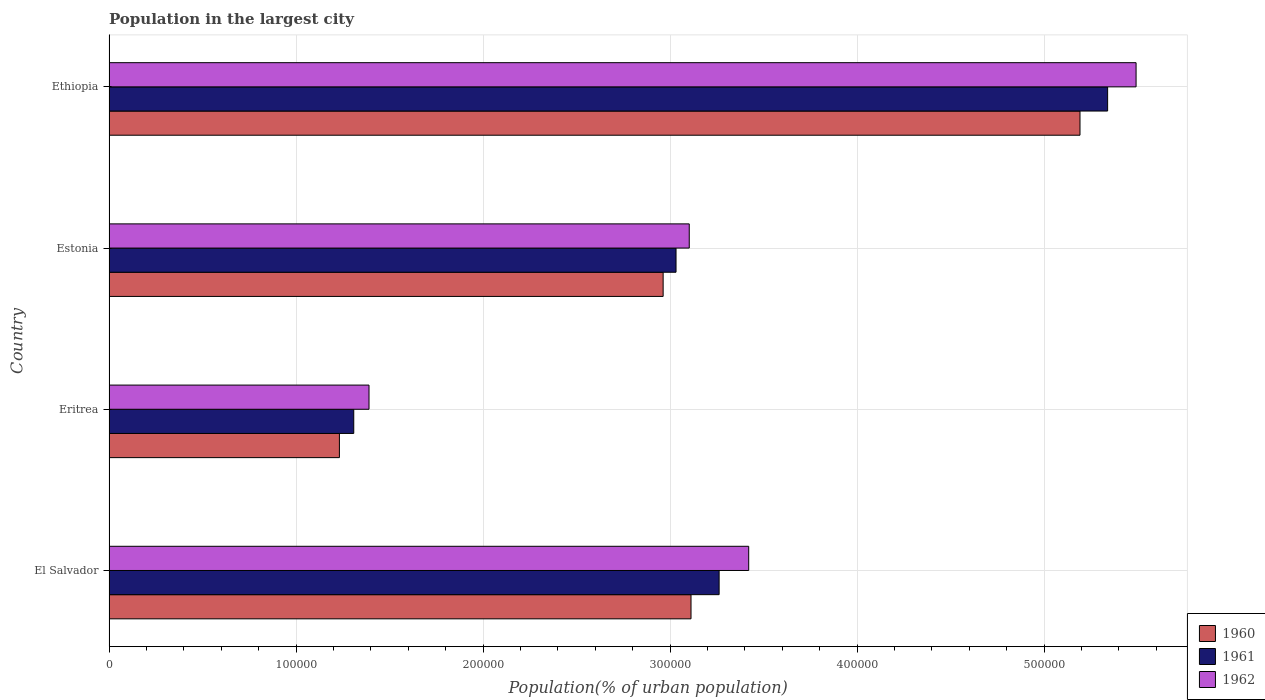How many groups of bars are there?
Keep it short and to the point. 4. Are the number of bars per tick equal to the number of legend labels?
Ensure brevity in your answer.  Yes. How many bars are there on the 4th tick from the bottom?
Offer a terse response. 3. What is the label of the 4th group of bars from the top?
Provide a succinct answer. El Salvador. What is the population in the largest city in 1962 in Estonia?
Keep it short and to the point. 3.10e+05. Across all countries, what is the maximum population in the largest city in 1960?
Keep it short and to the point. 5.19e+05. Across all countries, what is the minimum population in the largest city in 1960?
Offer a terse response. 1.23e+05. In which country was the population in the largest city in 1962 maximum?
Ensure brevity in your answer.  Ethiopia. In which country was the population in the largest city in 1960 minimum?
Give a very brief answer. Eritrea. What is the total population in the largest city in 1962 in the graph?
Your response must be concise. 1.34e+06. What is the difference between the population in the largest city in 1960 in El Salvador and that in Eritrea?
Make the answer very short. 1.88e+05. What is the difference between the population in the largest city in 1960 in El Salvador and the population in the largest city in 1961 in Ethiopia?
Provide a succinct answer. -2.23e+05. What is the average population in the largest city in 1961 per country?
Offer a terse response. 3.24e+05. What is the difference between the population in the largest city in 1962 and population in the largest city in 1960 in Estonia?
Make the answer very short. 1.40e+04. What is the ratio of the population in the largest city in 1960 in Eritrea to that in Ethiopia?
Provide a succinct answer. 0.24. Is the difference between the population in the largest city in 1962 in El Salvador and Ethiopia greater than the difference between the population in the largest city in 1960 in El Salvador and Ethiopia?
Provide a succinct answer. Yes. What is the difference between the highest and the second highest population in the largest city in 1962?
Offer a terse response. 2.07e+05. What is the difference between the highest and the lowest population in the largest city in 1962?
Offer a very short reply. 4.10e+05. How many bars are there?
Your answer should be compact. 12. Are all the bars in the graph horizontal?
Ensure brevity in your answer.  Yes. How many countries are there in the graph?
Provide a short and direct response. 4. Does the graph contain grids?
Give a very brief answer. Yes. Where does the legend appear in the graph?
Provide a short and direct response. Bottom right. How many legend labels are there?
Your response must be concise. 3. How are the legend labels stacked?
Provide a succinct answer. Vertical. What is the title of the graph?
Keep it short and to the point. Population in the largest city. Does "1986" appear as one of the legend labels in the graph?
Provide a succinct answer. No. What is the label or title of the X-axis?
Your answer should be compact. Population(% of urban population). What is the Population(% of urban population) in 1960 in El Salvador?
Your answer should be compact. 3.11e+05. What is the Population(% of urban population) in 1961 in El Salvador?
Ensure brevity in your answer.  3.26e+05. What is the Population(% of urban population) of 1962 in El Salvador?
Provide a succinct answer. 3.42e+05. What is the Population(% of urban population) of 1960 in Eritrea?
Your response must be concise. 1.23e+05. What is the Population(% of urban population) of 1961 in Eritrea?
Your response must be concise. 1.31e+05. What is the Population(% of urban population) in 1962 in Eritrea?
Ensure brevity in your answer.  1.39e+05. What is the Population(% of urban population) in 1960 in Estonia?
Your response must be concise. 2.96e+05. What is the Population(% of urban population) in 1961 in Estonia?
Ensure brevity in your answer.  3.03e+05. What is the Population(% of urban population) in 1962 in Estonia?
Offer a very short reply. 3.10e+05. What is the Population(% of urban population) in 1960 in Ethiopia?
Your response must be concise. 5.19e+05. What is the Population(% of urban population) of 1961 in Ethiopia?
Offer a terse response. 5.34e+05. What is the Population(% of urban population) of 1962 in Ethiopia?
Give a very brief answer. 5.49e+05. Across all countries, what is the maximum Population(% of urban population) in 1960?
Offer a very short reply. 5.19e+05. Across all countries, what is the maximum Population(% of urban population) of 1961?
Your answer should be compact. 5.34e+05. Across all countries, what is the maximum Population(% of urban population) of 1962?
Give a very brief answer. 5.49e+05. Across all countries, what is the minimum Population(% of urban population) of 1960?
Keep it short and to the point. 1.23e+05. Across all countries, what is the minimum Population(% of urban population) in 1961?
Your answer should be compact. 1.31e+05. Across all countries, what is the minimum Population(% of urban population) in 1962?
Make the answer very short. 1.39e+05. What is the total Population(% of urban population) in 1960 in the graph?
Offer a very short reply. 1.25e+06. What is the total Population(% of urban population) in 1961 in the graph?
Offer a terse response. 1.29e+06. What is the total Population(% of urban population) in 1962 in the graph?
Keep it short and to the point. 1.34e+06. What is the difference between the Population(% of urban population) in 1960 in El Salvador and that in Eritrea?
Make the answer very short. 1.88e+05. What is the difference between the Population(% of urban population) in 1961 in El Salvador and that in Eritrea?
Offer a terse response. 1.95e+05. What is the difference between the Population(% of urban population) in 1962 in El Salvador and that in Eritrea?
Your response must be concise. 2.03e+05. What is the difference between the Population(% of urban population) of 1960 in El Salvador and that in Estonia?
Offer a terse response. 1.49e+04. What is the difference between the Population(% of urban population) in 1961 in El Salvador and that in Estonia?
Keep it short and to the point. 2.30e+04. What is the difference between the Population(% of urban population) in 1962 in El Salvador and that in Estonia?
Make the answer very short. 3.18e+04. What is the difference between the Population(% of urban population) in 1960 in El Salvador and that in Ethiopia?
Make the answer very short. -2.08e+05. What is the difference between the Population(% of urban population) in 1961 in El Salvador and that in Ethiopia?
Your response must be concise. -2.08e+05. What is the difference between the Population(% of urban population) of 1962 in El Salvador and that in Ethiopia?
Provide a succinct answer. -2.07e+05. What is the difference between the Population(% of urban population) of 1960 in Eritrea and that in Estonia?
Make the answer very short. -1.73e+05. What is the difference between the Population(% of urban population) in 1961 in Eritrea and that in Estonia?
Your answer should be compact. -1.72e+05. What is the difference between the Population(% of urban population) of 1962 in Eritrea and that in Estonia?
Give a very brief answer. -1.71e+05. What is the difference between the Population(% of urban population) in 1960 in Eritrea and that in Ethiopia?
Your answer should be very brief. -3.96e+05. What is the difference between the Population(% of urban population) in 1961 in Eritrea and that in Ethiopia?
Give a very brief answer. -4.03e+05. What is the difference between the Population(% of urban population) of 1962 in Eritrea and that in Ethiopia?
Your answer should be very brief. -4.10e+05. What is the difference between the Population(% of urban population) of 1960 in Estonia and that in Ethiopia?
Provide a succinct answer. -2.23e+05. What is the difference between the Population(% of urban population) of 1961 in Estonia and that in Ethiopia?
Provide a short and direct response. -2.31e+05. What is the difference between the Population(% of urban population) of 1962 in Estonia and that in Ethiopia?
Ensure brevity in your answer.  -2.39e+05. What is the difference between the Population(% of urban population) in 1960 in El Salvador and the Population(% of urban population) in 1961 in Eritrea?
Make the answer very short. 1.80e+05. What is the difference between the Population(% of urban population) of 1960 in El Salvador and the Population(% of urban population) of 1962 in Eritrea?
Your response must be concise. 1.72e+05. What is the difference between the Population(% of urban population) of 1961 in El Salvador and the Population(% of urban population) of 1962 in Eritrea?
Make the answer very short. 1.87e+05. What is the difference between the Population(% of urban population) in 1960 in El Salvador and the Population(% of urban population) in 1961 in Estonia?
Provide a succinct answer. 8011. What is the difference between the Population(% of urban population) of 1960 in El Salvador and the Population(% of urban population) of 1962 in Estonia?
Make the answer very short. 942. What is the difference between the Population(% of urban population) of 1961 in El Salvador and the Population(% of urban population) of 1962 in Estonia?
Offer a terse response. 1.60e+04. What is the difference between the Population(% of urban population) of 1960 in El Salvador and the Population(% of urban population) of 1961 in Ethiopia?
Provide a short and direct response. -2.23e+05. What is the difference between the Population(% of urban population) of 1960 in El Salvador and the Population(% of urban population) of 1962 in Ethiopia?
Ensure brevity in your answer.  -2.38e+05. What is the difference between the Population(% of urban population) in 1961 in El Salvador and the Population(% of urban population) in 1962 in Ethiopia?
Provide a short and direct response. -2.23e+05. What is the difference between the Population(% of urban population) of 1960 in Eritrea and the Population(% of urban population) of 1961 in Estonia?
Offer a terse response. -1.80e+05. What is the difference between the Population(% of urban population) of 1960 in Eritrea and the Population(% of urban population) of 1962 in Estonia?
Your answer should be very brief. -1.87e+05. What is the difference between the Population(% of urban population) in 1961 in Eritrea and the Population(% of urban population) in 1962 in Estonia?
Ensure brevity in your answer.  -1.79e+05. What is the difference between the Population(% of urban population) in 1960 in Eritrea and the Population(% of urban population) in 1961 in Ethiopia?
Your answer should be very brief. -4.11e+05. What is the difference between the Population(% of urban population) in 1960 in Eritrea and the Population(% of urban population) in 1962 in Ethiopia?
Your answer should be very brief. -4.26e+05. What is the difference between the Population(% of urban population) of 1961 in Eritrea and the Population(% of urban population) of 1962 in Ethiopia?
Offer a very short reply. -4.18e+05. What is the difference between the Population(% of urban population) in 1960 in Estonia and the Population(% of urban population) in 1961 in Ethiopia?
Keep it short and to the point. -2.38e+05. What is the difference between the Population(% of urban population) of 1960 in Estonia and the Population(% of urban population) of 1962 in Ethiopia?
Make the answer very short. -2.53e+05. What is the difference between the Population(% of urban population) of 1961 in Estonia and the Population(% of urban population) of 1962 in Ethiopia?
Your answer should be compact. -2.46e+05. What is the average Population(% of urban population) of 1960 per country?
Offer a terse response. 3.12e+05. What is the average Population(% of urban population) in 1961 per country?
Provide a short and direct response. 3.24e+05. What is the average Population(% of urban population) in 1962 per country?
Provide a short and direct response. 3.35e+05. What is the difference between the Population(% of urban population) of 1960 and Population(% of urban population) of 1961 in El Salvador?
Your response must be concise. -1.50e+04. What is the difference between the Population(% of urban population) in 1960 and Population(% of urban population) in 1962 in El Salvador?
Provide a short and direct response. -3.08e+04. What is the difference between the Population(% of urban population) of 1961 and Population(% of urban population) of 1962 in El Salvador?
Keep it short and to the point. -1.58e+04. What is the difference between the Population(% of urban population) in 1960 and Population(% of urban population) in 1961 in Eritrea?
Make the answer very short. -7673. What is the difference between the Population(% of urban population) in 1960 and Population(% of urban population) in 1962 in Eritrea?
Ensure brevity in your answer.  -1.58e+04. What is the difference between the Population(% of urban population) in 1961 and Population(% of urban population) in 1962 in Eritrea?
Offer a terse response. -8161. What is the difference between the Population(% of urban population) of 1960 and Population(% of urban population) of 1961 in Estonia?
Provide a short and direct response. -6898. What is the difference between the Population(% of urban population) in 1960 and Population(% of urban population) in 1962 in Estonia?
Your answer should be compact. -1.40e+04. What is the difference between the Population(% of urban population) in 1961 and Population(% of urban population) in 1962 in Estonia?
Provide a succinct answer. -7069. What is the difference between the Population(% of urban population) of 1960 and Population(% of urban population) of 1961 in Ethiopia?
Offer a very short reply. -1.48e+04. What is the difference between the Population(% of urban population) in 1960 and Population(% of urban population) in 1962 in Ethiopia?
Your response must be concise. -3.00e+04. What is the difference between the Population(% of urban population) in 1961 and Population(% of urban population) in 1962 in Ethiopia?
Offer a terse response. -1.52e+04. What is the ratio of the Population(% of urban population) of 1960 in El Salvador to that in Eritrea?
Keep it short and to the point. 2.53. What is the ratio of the Population(% of urban population) of 1961 in El Salvador to that in Eritrea?
Provide a succinct answer. 2.49. What is the ratio of the Population(% of urban population) in 1962 in El Salvador to that in Eritrea?
Provide a succinct answer. 2.46. What is the ratio of the Population(% of urban population) of 1960 in El Salvador to that in Estonia?
Your answer should be very brief. 1.05. What is the ratio of the Population(% of urban population) in 1961 in El Salvador to that in Estonia?
Provide a short and direct response. 1.08. What is the ratio of the Population(% of urban population) of 1962 in El Salvador to that in Estonia?
Your answer should be compact. 1.1. What is the ratio of the Population(% of urban population) of 1960 in El Salvador to that in Ethiopia?
Give a very brief answer. 0.6. What is the ratio of the Population(% of urban population) of 1961 in El Salvador to that in Ethiopia?
Keep it short and to the point. 0.61. What is the ratio of the Population(% of urban population) of 1962 in El Salvador to that in Ethiopia?
Keep it short and to the point. 0.62. What is the ratio of the Population(% of urban population) in 1960 in Eritrea to that in Estonia?
Offer a very short reply. 0.42. What is the ratio of the Population(% of urban population) of 1961 in Eritrea to that in Estonia?
Your answer should be very brief. 0.43. What is the ratio of the Population(% of urban population) of 1962 in Eritrea to that in Estonia?
Give a very brief answer. 0.45. What is the ratio of the Population(% of urban population) of 1960 in Eritrea to that in Ethiopia?
Ensure brevity in your answer.  0.24. What is the ratio of the Population(% of urban population) in 1961 in Eritrea to that in Ethiopia?
Offer a terse response. 0.25. What is the ratio of the Population(% of urban population) in 1962 in Eritrea to that in Ethiopia?
Provide a succinct answer. 0.25. What is the ratio of the Population(% of urban population) of 1960 in Estonia to that in Ethiopia?
Your answer should be compact. 0.57. What is the ratio of the Population(% of urban population) of 1961 in Estonia to that in Ethiopia?
Provide a succinct answer. 0.57. What is the ratio of the Population(% of urban population) of 1962 in Estonia to that in Ethiopia?
Offer a very short reply. 0.56. What is the difference between the highest and the second highest Population(% of urban population) in 1960?
Ensure brevity in your answer.  2.08e+05. What is the difference between the highest and the second highest Population(% of urban population) of 1961?
Your answer should be very brief. 2.08e+05. What is the difference between the highest and the second highest Population(% of urban population) in 1962?
Your response must be concise. 2.07e+05. What is the difference between the highest and the lowest Population(% of urban population) in 1960?
Your response must be concise. 3.96e+05. What is the difference between the highest and the lowest Population(% of urban population) of 1961?
Your answer should be compact. 4.03e+05. What is the difference between the highest and the lowest Population(% of urban population) in 1962?
Your answer should be compact. 4.10e+05. 